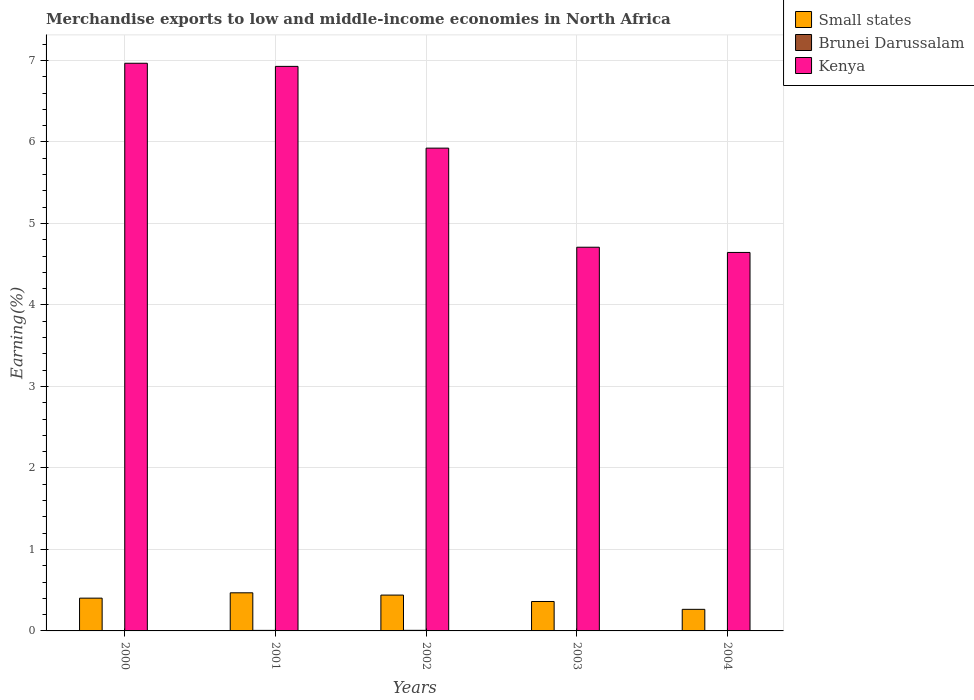How many different coloured bars are there?
Make the answer very short. 3. Are the number of bars per tick equal to the number of legend labels?
Provide a succinct answer. Yes. Are the number of bars on each tick of the X-axis equal?
Keep it short and to the point. Yes. How many bars are there on the 4th tick from the right?
Offer a terse response. 3. What is the label of the 3rd group of bars from the left?
Your response must be concise. 2002. In how many cases, is the number of bars for a given year not equal to the number of legend labels?
Provide a short and direct response. 0. What is the percentage of amount earned from merchandise exports in Kenya in 2000?
Your answer should be very brief. 6.97. Across all years, what is the maximum percentage of amount earned from merchandise exports in Small states?
Your response must be concise. 0.47. Across all years, what is the minimum percentage of amount earned from merchandise exports in Kenya?
Provide a succinct answer. 4.64. In which year was the percentage of amount earned from merchandise exports in Kenya minimum?
Offer a very short reply. 2004. What is the total percentage of amount earned from merchandise exports in Brunei Darussalam in the graph?
Make the answer very short. 0.02. What is the difference between the percentage of amount earned from merchandise exports in Small states in 2001 and that in 2003?
Offer a terse response. 0.11. What is the difference between the percentage of amount earned from merchandise exports in Kenya in 2000 and the percentage of amount earned from merchandise exports in Small states in 2003?
Offer a terse response. 6.6. What is the average percentage of amount earned from merchandise exports in Small states per year?
Ensure brevity in your answer.  0.39. In the year 2000, what is the difference between the percentage of amount earned from merchandise exports in Kenya and percentage of amount earned from merchandise exports in Brunei Darussalam?
Your answer should be very brief. 6.96. What is the ratio of the percentage of amount earned from merchandise exports in Small states in 2000 to that in 2002?
Offer a terse response. 0.91. Is the percentage of amount earned from merchandise exports in Brunei Darussalam in 2002 less than that in 2003?
Keep it short and to the point. No. What is the difference between the highest and the second highest percentage of amount earned from merchandise exports in Small states?
Give a very brief answer. 0.03. What is the difference between the highest and the lowest percentage of amount earned from merchandise exports in Kenya?
Make the answer very short. 2.32. What does the 1st bar from the left in 2000 represents?
Offer a terse response. Small states. What does the 2nd bar from the right in 2001 represents?
Your answer should be compact. Brunei Darussalam. How many bars are there?
Offer a very short reply. 15. Are all the bars in the graph horizontal?
Offer a very short reply. No. How many years are there in the graph?
Give a very brief answer. 5. How many legend labels are there?
Provide a short and direct response. 3. What is the title of the graph?
Offer a very short reply. Merchandise exports to low and middle-income economies in North Africa. What is the label or title of the X-axis?
Offer a terse response. Years. What is the label or title of the Y-axis?
Your answer should be compact. Earning(%). What is the Earning(%) in Small states in 2000?
Offer a very short reply. 0.4. What is the Earning(%) in Brunei Darussalam in 2000?
Your answer should be compact. 0. What is the Earning(%) in Kenya in 2000?
Offer a terse response. 6.97. What is the Earning(%) of Small states in 2001?
Keep it short and to the point. 0.47. What is the Earning(%) of Brunei Darussalam in 2001?
Provide a short and direct response. 0.01. What is the Earning(%) in Kenya in 2001?
Your response must be concise. 6.93. What is the Earning(%) in Small states in 2002?
Offer a terse response. 0.44. What is the Earning(%) in Brunei Darussalam in 2002?
Offer a very short reply. 0.01. What is the Earning(%) in Kenya in 2002?
Make the answer very short. 5.92. What is the Earning(%) in Small states in 2003?
Provide a short and direct response. 0.36. What is the Earning(%) of Brunei Darussalam in 2003?
Offer a terse response. 0. What is the Earning(%) of Kenya in 2003?
Offer a very short reply. 4.71. What is the Earning(%) of Small states in 2004?
Your response must be concise. 0.26. What is the Earning(%) of Brunei Darussalam in 2004?
Keep it short and to the point. 0. What is the Earning(%) in Kenya in 2004?
Make the answer very short. 4.64. Across all years, what is the maximum Earning(%) in Small states?
Make the answer very short. 0.47. Across all years, what is the maximum Earning(%) of Brunei Darussalam?
Make the answer very short. 0.01. Across all years, what is the maximum Earning(%) in Kenya?
Make the answer very short. 6.97. Across all years, what is the minimum Earning(%) in Small states?
Give a very brief answer. 0.26. Across all years, what is the minimum Earning(%) in Brunei Darussalam?
Provide a succinct answer. 0. Across all years, what is the minimum Earning(%) of Kenya?
Make the answer very short. 4.64. What is the total Earning(%) of Small states in the graph?
Make the answer very short. 1.94. What is the total Earning(%) in Brunei Darussalam in the graph?
Make the answer very short. 0.02. What is the total Earning(%) of Kenya in the graph?
Your response must be concise. 29.17. What is the difference between the Earning(%) in Small states in 2000 and that in 2001?
Ensure brevity in your answer.  -0.07. What is the difference between the Earning(%) in Brunei Darussalam in 2000 and that in 2001?
Your answer should be compact. -0. What is the difference between the Earning(%) of Kenya in 2000 and that in 2001?
Offer a very short reply. 0.04. What is the difference between the Earning(%) in Small states in 2000 and that in 2002?
Ensure brevity in your answer.  -0.04. What is the difference between the Earning(%) in Brunei Darussalam in 2000 and that in 2002?
Keep it short and to the point. -0. What is the difference between the Earning(%) in Kenya in 2000 and that in 2002?
Offer a very short reply. 1.04. What is the difference between the Earning(%) of Small states in 2000 and that in 2003?
Offer a very short reply. 0.04. What is the difference between the Earning(%) of Brunei Darussalam in 2000 and that in 2003?
Offer a terse response. 0. What is the difference between the Earning(%) of Kenya in 2000 and that in 2003?
Offer a very short reply. 2.26. What is the difference between the Earning(%) in Small states in 2000 and that in 2004?
Offer a very short reply. 0.14. What is the difference between the Earning(%) of Brunei Darussalam in 2000 and that in 2004?
Keep it short and to the point. 0. What is the difference between the Earning(%) of Kenya in 2000 and that in 2004?
Offer a very short reply. 2.32. What is the difference between the Earning(%) of Small states in 2001 and that in 2002?
Offer a terse response. 0.03. What is the difference between the Earning(%) in Brunei Darussalam in 2001 and that in 2002?
Offer a terse response. -0. What is the difference between the Earning(%) of Small states in 2001 and that in 2003?
Provide a short and direct response. 0.11. What is the difference between the Earning(%) of Brunei Darussalam in 2001 and that in 2003?
Your answer should be very brief. 0. What is the difference between the Earning(%) of Kenya in 2001 and that in 2003?
Ensure brevity in your answer.  2.22. What is the difference between the Earning(%) in Small states in 2001 and that in 2004?
Make the answer very short. 0.2. What is the difference between the Earning(%) of Brunei Darussalam in 2001 and that in 2004?
Provide a succinct answer. 0.01. What is the difference between the Earning(%) in Kenya in 2001 and that in 2004?
Offer a very short reply. 2.28. What is the difference between the Earning(%) of Small states in 2002 and that in 2003?
Your answer should be compact. 0.08. What is the difference between the Earning(%) in Brunei Darussalam in 2002 and that in 2003?
Ensure brevity in your answer.  0. What is the difference between the Earning(%) of Kenya in 2002 and that in 2003?
Keep it short and to the point. 1.22. What is the difference between the Earning(%) in Small states in 2002 and that in 2004?
Your answer should be very brief. 0.17. What is the difference between the Earning(%) of Brunei Darussalam in 2002 and that in 2004?
Your answer should be very brief. 0.01. What is the difference between the Earning(%) of Kenya in 2002 and that in 2004?
Offer a very short reply. 1.28. What is the difference between the Earning(%) of Small states in 2003 and that in 2004?
Your answer should be compact. 0.1. What is the difference between the Earning(%) in Brunei Darussalam in 2003 and that in 2004?
Make the answer very short. 0. What is the difference between the Earning(%) of Kenya in 2003 and that in 2004?
Provide a short and direct response. 0.06. What is the difference between the Earning(%) of Small states in 2000 and the Earning(%) of Brunei Darussalam in 2001?
Make the answer very short. 0.4. What is the difference between the Earning(%) in Small states in 2000 and the Earning(%) in Kenya in 2001?
Provide a short and direct response. -6.53. What is the difference between the Earning(%) of Brunei Darussalam in 2000 and the Earning(%) of Kenya in 2001?
Provide a succinct answer. -6.92. What is the difference between the Earning(%) in Small states in 2000 and the Earning(%) in Brunei Darussalam in 2002?
Give a very brief answer. 0.4. What is the difference between the Earning(%) of Small states in 2000 and the Earning(%) of Kenya in 2002?
Provide a short and direct response. -5.52. What is the difference between the Earning(%) in Brunei Darussalam in 2000 and the Earning(%) in Kenya in 2002?
Provide a short and direct response. -5.92. What is the difference between the Earning(%) of Small states in 2000 and the Earning(%) of Brunei Darussalam in 2003?
Make the answer very short. 0.4. What is the difference between the Earning(%) in Small states in 2000 and the Earning(%) in Kenya in 2003?
Make the answer very short. -4.31. What is the difference between the Earning(%) of Brunei Darussalam in 2000 and the Earning(%) of Kenya in 2003?
Provide a short and direct response. -4.7. What is the difference between the Earning(%) of Small states in 2000 and the Earning(%) of Brunei Darussalam in 2004?
Provide a succinct answer. 0.4. What is the difference between the Earning(%) in Small states in 2000 and the Earning(%) in Kenya in 2004?
Make the answer very short. -4.24. What is the difference between the Earning(%) in Brunei Darussalam in 2000 and the Earning(%) in Kenya in 2004?
Provide a succinct answer. -4.64. What is the difference between the Earning(%) in Small states in 2001 and the Earning(%) in Brunei Darussalam in 2002?
Your response must be concise. 0.46. What is the difference between the Earning(%) of Small states in 2001 and the Earning(%) of Kenya in 2002?
Your response must be concise. -5.46. What is the difference between the Earning(%) of Brunei Darussalam in 2001 and the Earning(%) of Kenya in 2002?
Provide a succinct answer. -5.92. What is the difference between the Earning(%) of Small states in 2001 and the Earning(%) of Brunei Darussalam in 2003?
Your answer should be compact. 0.46. What is the difference between the Earning(%) in Small states in 2001 and the Earning(%) in Kenya in 2003?
Ensure brevity in your answer.  -4.24. What is the difference between the Earning(%) of Brunei Darussalam in 2001 and the Earning(%) of Kenya in 2003?
Your answer should be very brief. -4.7. What is the difference between the Earning(%) in Small states in 2001 and the Earning(%) in Brunei Darussalam in 2004?
Make the answer very short. 0.47. What is the difference between the Earning(%) of Small states in 2001 and the Earning(%) of Kenya in 2004?
Your answer should be very brief. -4.18. What is the difference between the Earning(%) of Brunei Darussalam in 2001 and the Earning(%) of Kenya in 2004?
Keep it short and to the point. -4.64. What is the difference between the Earning(%) of Small states in 2002 and the Earning(%) of Brunei Darussalam in 2003?
Your response must be concise. 0.44. What is the difference between the Earning(%) in Small states in 2002 and the Earning(%) in Kenya in 2003?
Ensure brevity in your answer.  -4.27. What is the difference between the Earning(%) of Brunei Darussalam in 2002 and the Earning(%) of Kenya in 2003?
Ensure brevity in your answer.  -4.7. What is the difference between the Earning(%) of Small states in 2002 and the Earning(%) of Brunei Darussalam in 2004?
Provide a short and direct response. 0.44. What is the difference between the Earning(%) in Small states in 2002 and the Earning(%) in Kenya in 2004?
Keep it short and to the point. -4.2. What is the difference between the Earning(%) of Brunei Darussalam in 2002 and the Earning(%) of Kenya in 2004?
Offer a very short reply. -4.64. What is the difference between the Earning(%) of Small states in 2003 and the Earning(%) of Brunei Darussalam in 2004?
Your answer should be very brief. 0.36. What is the difference between the Earning(%) of Small states in 2003 and the Earning(%) of Kenya in 2004?
Your response must be concise. -4.28. What is the difference between the Earning(%) in Brunei Darussalam in 2003 and the Earning(%) in Kenya in 2004?
Make the answer very short. -4.64. What is the average Earning(%) in Small states per year?
Provide a succinct answer. 0.39. What is the average Earning(%) in Brunei Darussalam per year?
Offer a terse response. 0. What is the average Earning(%) in Kenya per year?
Make the answer very short. 5.83. In the year 2000, what is the difference between the Earning(%) in Small states and Earning(%) in Brunei Darussalam?
Give a very brief answer. 0.4. In the year 2000, what is the difference between the Earning(%) of Small states and Earning(%) of Kenya?
Keep it short and to the point. -6.56. In the year 2000, what is the difference between the Earning(%) of Brunei Darussalam and Earning(%) of Kenya?
Ensure brevity in your answer.  -6.96. In the year 2001, what is the difference between the Earning(%) in Small states and Earning(%) in Brunei Darussalam?
Your answer should be very brief. 0.46. In the year 2001, what is the difference between the Earning(%) in Small states and Earning(%) in Kenya?
Offer a very short reply. -6.46. In the year 2001, what is the difference between the Earning(%) in Brunei Darussalam and Earning(%) in Kenya?
Your response must be concise. -6.92. In the year 2002, what is the difference between the Earning(%) in Small states and Earning(%) in Brunei Darussalam?
Your answer should be compact. 0.43. In the year 2002, what is the difference between the Earning(%) in Small states and Earning(%) in Kenya?
Your response must be concise. -5.48. In the year 2002, what is the difference between the Earning(%) in Brunei Darussalam and Earning(%) in Kenya?
Your answer should be very brief. -5.92. In the year 2003, what is the difference between the Earning(%) of Small states and Earning(%) of Brunei Darussalam?
Give a very brief answer. 0.36. In the year 2003, what is the difference between the Earning(%) in Small states and Earning(%) in Kenya?
Provide a short and direct response. -4.35. In the year 2003, what is the difference between the Earning(%) of Brunei Darussalam and Earning(%) of Kenya?
Your response must be concise. -4.71. In the year 2004, what is the difference between the Earning(%) of Small states and Earning(%) of Brunei Darussalam?
Keep it short and to the point. 0.26. In the year 2004, what is the difference between the Earning(%) in Small states and Earning(%) in Kenya?
Provide a succinct answer. -4.38. In the year 2004, what is the difference between the Earning(%) of Brunei Darussalam and Earning(%) of Kenya?
Ensure brevity in your answer.  -4.64. What is the ratio of the Earning(%) of Small states in 2000 to that in 2001?
Offer a terse response. 0.86. What is the ratio of the Earning(%) in Brunei Darussalam in 2000 to that in 2001?
Make the answer very short. 0.6. What is the ratio of the Earning(%) of Small states in 2000 to that in 2002?
Your answer should be very brief. 0.91. What is the ratio of the Earning(%) in Brunei Darussalam in 2000 to that in 2002?
Offer a very short reply. 0.56. What is the ratio of the Earning(%) of Kenya in 2000 to that in 2002?
Offer a terse response. 1.18. What is the ratio of the Earning(%) of Small states in 2000 to that in 2003?
Provide a short and direct response. 1.11. What is the ratio of the Earning(%) in Brunei Darussalam in 2000 to that in 2003?
Your response must be concise. 1.37. What is the ratio of the Earning(%) in Kenya in 2000 to that in 2003?
Ensure brevity in your answer.  1.48. What is the ratio of the Earning(%) in Small states in 2000 to that in 2004?
Give a very brief answer. 1.52. What is the ratio of the Earning(%) of Brunei Darussalam in 2000 to that in 2004?
Offer a very short reply. 3.86. What is the ratio of the Earning(%) of Kenya in 2000 to that in 2004?
Your answer should be compact. 1.5. What is the ratio of the Earning(%) in Small states in 2001 to that in 2002?
Ensure brevity in your answer.  1.06. What is the ratio of the Earning(%) in Brunei Darussalam in 2001 to that in 2002?
Make the answer very short. 0.93. What is the ratio of the Earning(%) in Kenya in 2001 to that in 2002?
Offer a terse response. 1.17. What is the ratio of the Earning(%) in Small states in 2001 to that in 2003?
Provide a succinct answer. 1.3. What is the ratio of the Earning(%) in Brunei Darussalam in 2001 to that in 2003?
Your answer should be compact. 2.29. What is the ratio of the Earning(%) in Kenya in 2001 to that in 2003?
Ensure brevity in your answer.  1.47. What is the ratio of the Earning(%) of Small states in 2001 to that in 2004?
Make the answer very short. 1.77. What is the ratio of the Earning(%) of Brunei Darussalam in 2001 to that in 2004?
Your response must be concise. 6.43. What is the ratio of the Earning(%) in Kenya in 2001 to that in 2004?
Make the answer very short. 1.49. What is the ratio of the Earning(%) of Small states in 2002 to that in 2003?
Your answer should be compact. 1.22. What is the ratio of the Earning(%) in Brunei Darussalam in 2002 to that in 2003?
Your response must be concise. 2.46. What is the ratio of the Earning(%) of Kenya in 2002 to that in 2003?
Your answer should be very brief. 1.26. What is the ratio of the Earning(%) in Small states in 2002 to that in 2004?
Your answer should be very brief. 1.66. What is the ratio of the Earning(%) of Brunei Darussalam in 2002 to that in 2004?
Give a very brief answer. 6.9. What is the ratio of the Earning(%) of Kenya in 2002 to that in 2004?
Keep it short and to the point. 1.28. What is the ratio of the Earning(%) in Small states in 2003 to that in 2004?
Your response must be concise. 1.36. What is the ratio of the Earning(%) of Brunei Darussalam in 2003 to that in 2004?
Give a very brief answer. 2.81. What is the ratio of the Earning(%) of Kenya in 2003 to that in 2004?
Keep it short and to the point. 1.01. What is the difference between the highest and the second highest Earning(%) in Small states?
Your answer should be very brief. 0.03. What is the difference between the highest and the second highest Earning(%) in Kenya?
Make the answer very short. 0.04. What is the difference between the highest and the lowest Earning(%) of Small states?
Offer a very short reply. 0.2. What is the difference between the highest and the lowest Earning(%) of Brunei Darussalam?
Your answer should be compact. 0.01. What is the difference between the highest and the lowest Earning(%) of Kenya?
Ensure brevity in your answer.  2.32. 